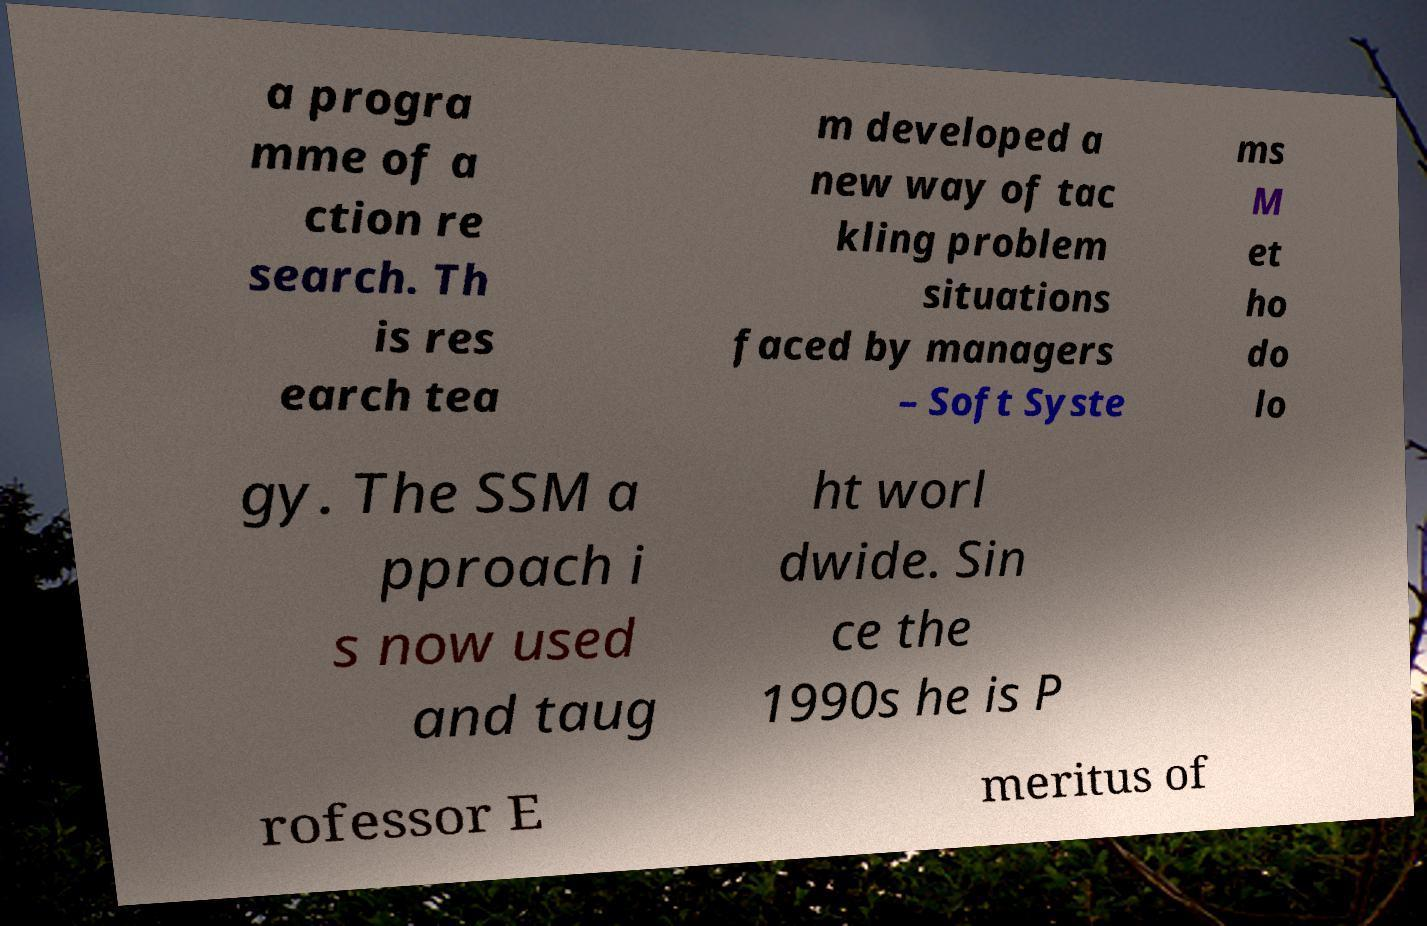Can you read and provide the text displayed in the image?This photo seems to have some interesting text. Can you extract and type it out for me? a progra mme of a ction re search. Th is res earch tea m developed a new way of tac kling problem situations faced by managers – Soft Syste ms M et ho do lo gy. The SSM a pproach i s now used and taug ht worl dwide. Sin ce the 1990s he is P rofessor E meritus of 